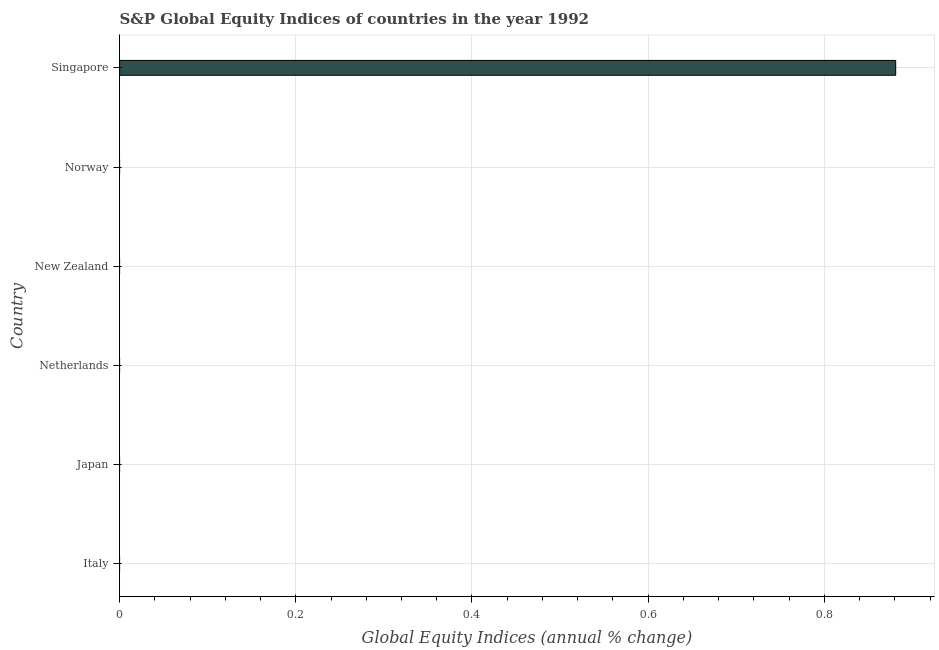Does the graph contain grids?
Give a very brief answer. Yes. What is the title of the graph?
Make the answer very short. S&P Global Equity Indices of countries in the year 1992. What is the label or title of the X-axis?
Ensure brevity in your answer.  Global Equity Indices (annual % change). What is the label or title of the Y-axis?
Your response must be concise. Country. What is the s&p global equity indices in Italy?
Your response must be concise. 0. Across all countries, what is the maximum s&p global equity indices?
Offer a very short reply. 0.88. In which country was the s&p global equity indices maximum?
Your response must be concise. Singapore. What is the sum of the s&p global equity indices?
Offer a terse response. 0.88. What is the average s&p global equity indices per country?
Keep it short and to the point. 0.15. What is the median s&p global equity indices?
Your response must be concise. 0. In how many countries, is the s&p global equity indices greater than 0.84 %?
Provide a succinct answer. 1. What is the difference between the highest and the lowest s&p global equity indices?
Your answer should be very brief. 0.88. In how many countries, is the s&p global equity indices greater than the average s&p global equity indices taken over all countries?
Provide a succinct answer. 1. How many bars are there?
Make the answer very short. 1. Are all the bars in the graph horizontal?
Your response must be concise. Yes. How many countries are there in the graph?
Provide a short and direct response. 6. What is the Global Equity Indices (annual % change) in Italy?
Provide a succinct answer. 0. What is the Global Equity Indices (annual % change) in Netherlands?
Ensure brevity in your answer.  0. What is the Global Equity Indices (annual % change) in Norway?
Offer a very short reply. 0. What is the Global Equity Indices (annual % change) of Singapore?
Keep it short and to the point. 0.88. 